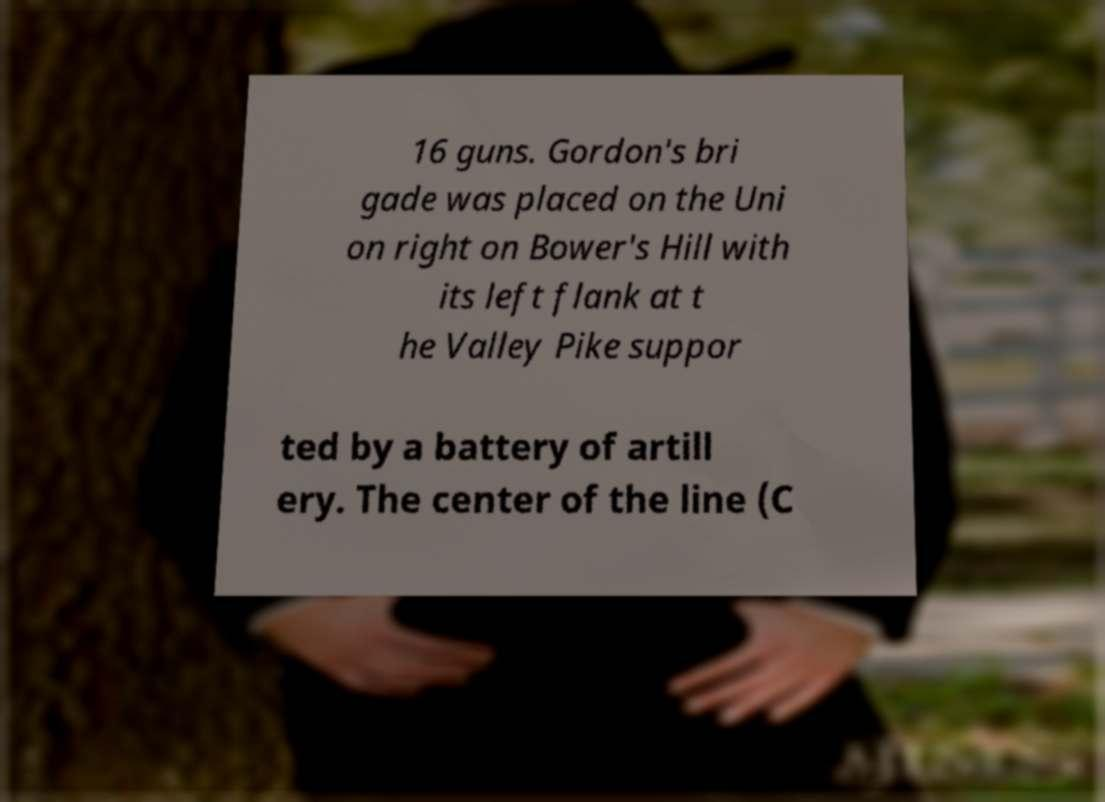There's text embedded in this image that I need extracted. Can you transcribe it verbatim? 16 guns. Gordon's bri gade was placed on the Uni on right on Bower's Hill with its left flank at t he Valley Pike suppor ted by a battery of artill ery. The center of the line (C 